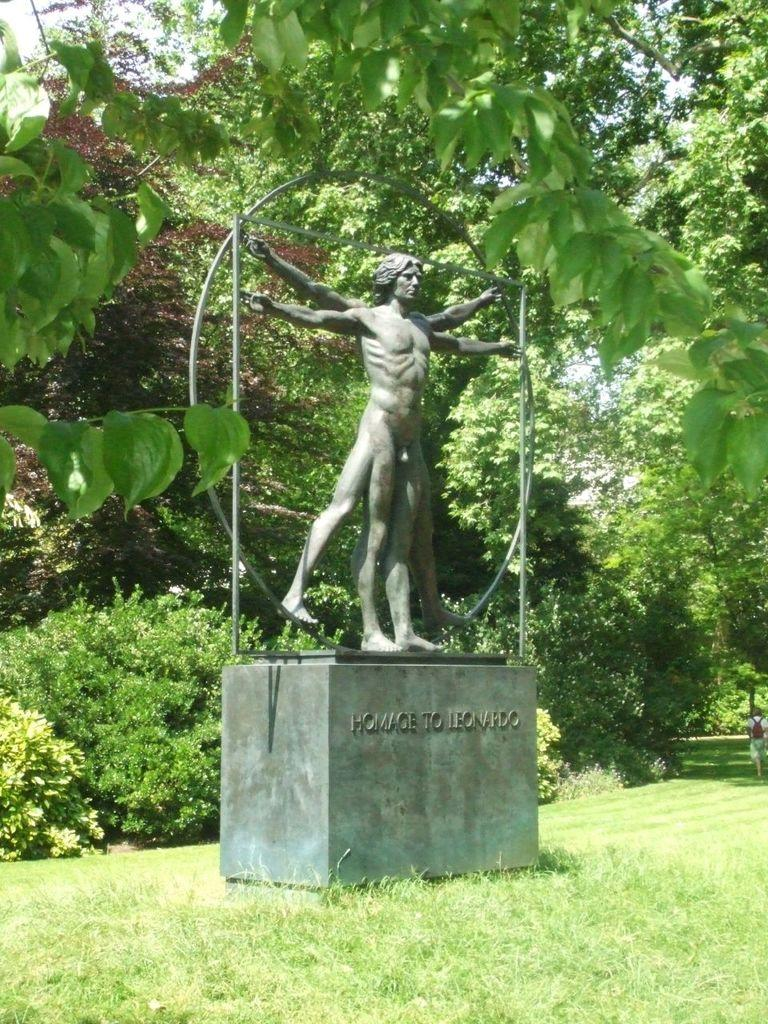What is the main subject of the image? There is a statue on a pedestal in the image. What is the surface beneath the statue? There is grass on the ground in the image. What can be seen in the distance behind the statue? There are trees in the background of the image. Is there any text or inscription on the pedestal? Yes, there is text on the pedestal. What type of powder is being used to clean the statue in the image? There is no indication of any cleaning activity or powder in the image. 